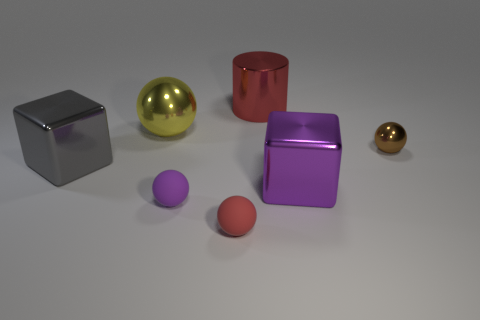Subtract all tiny spheres. How many spheres are left? 1 Add 2 yellow shiny objects. How many objects exist? 9 Subtract all purple blocks. How many blocks are left? 1 Subtract all balls. How many objects are left? 3 Subtract 1 balls. How many balls are left? 3 Subtract all large green cylinders. Subtract all red matte spheres. How many objects are left? 6 Add 1 brown metal spheres. How many brown metal spheres are left? 2 Add 1 tiny cyan things. How many tiny cyan things exist? 1 Subtract 1 gray cubes. How many objects are left? 6 Subtract all gray blocks. Subtract all red spheres. How many blocks are left? 1 